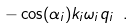<formula> <loc_0><loc_0><loc_500><loc_500>- \cos ( \alpha _ { i } ) k _ { i } \omega _ { i } q _ { i } \ .</formula> 